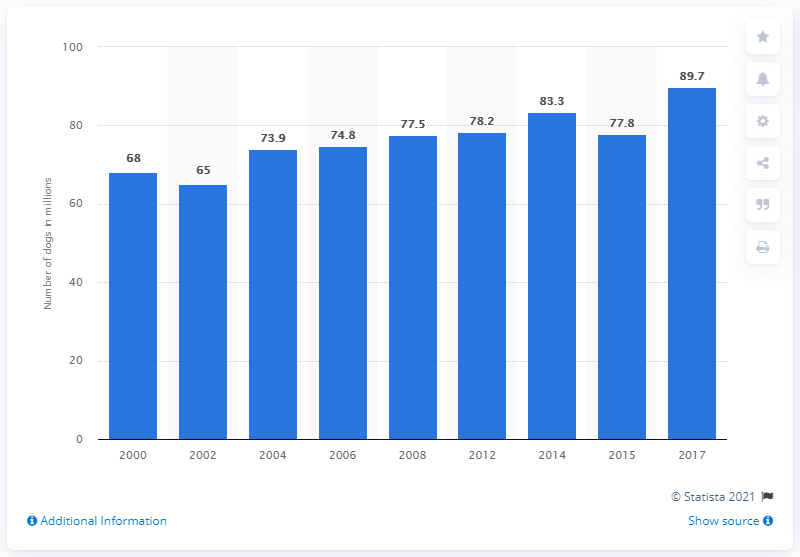Highlight a few significant elements in this photo. In 2017, there were 89.7 million dogs living in the United States. 